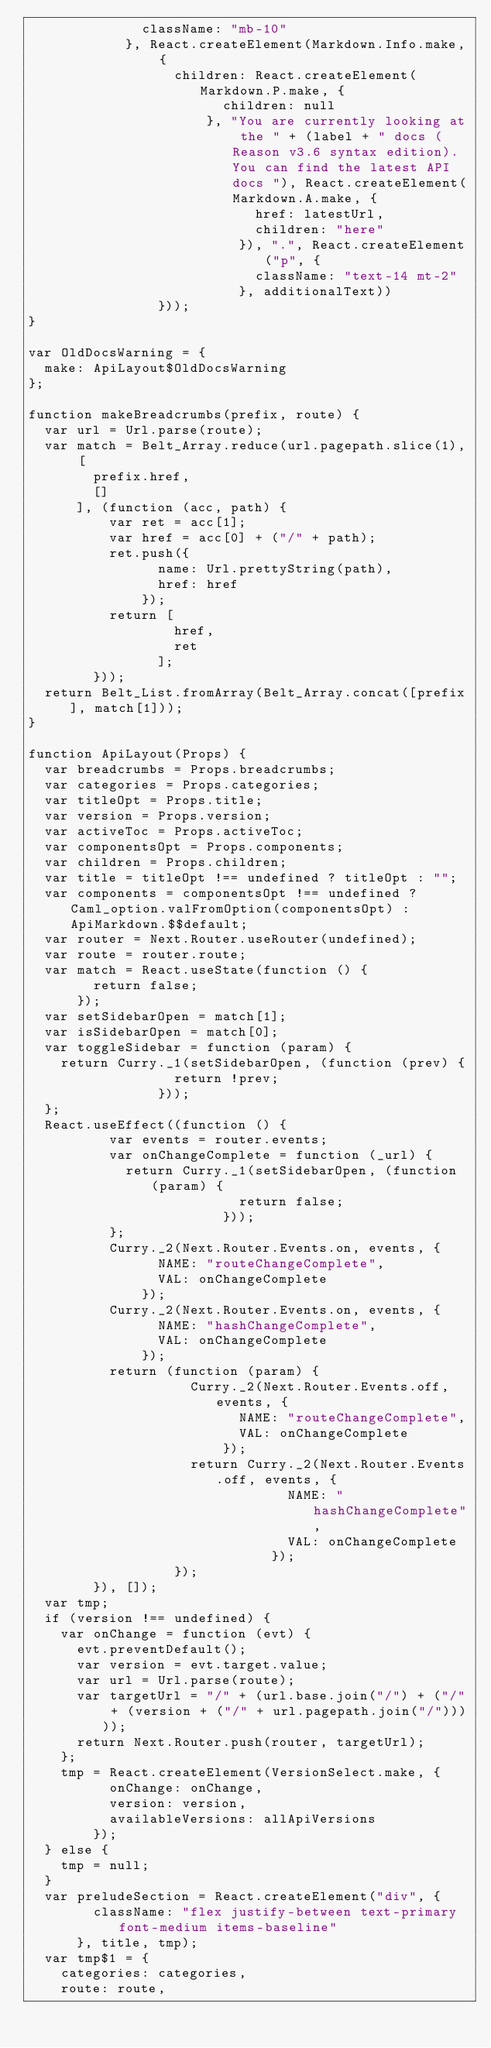Convert code to text. <code><loc_0><loc_0><loc_500><loc_500><_JavaScript_>              className: "mb-10"
            }, React.createElement(Markdown.Info.make, {
                  children: React.createElement(Markdown.P.make, {
                        children: null
                      }, "You are currently looking at the " + (label + " docs (Reason v3.6 syntax edition). You can find the latest API docs "), React.createElement(Markdown.A.make, {
                            href: latestUrl,
                            children: "here"
                          }), ".", React.createElement("p", {
                            className: "text-14 mt-2"
                          }, additionalText))
                }));
}

var OldDocsWarning = {
  make: ApiLayout$OldDocsWarning
};

function makeBreadcrumbs(prefix, route) {
  var url = Url.parse(route);
  var match = Belt_Array.reduce(url.pagepath.slice(1), [
        prefix.href,
        []
      ], (function (acc, path) {
          var ret = acc[1];
          var href = acc[0] + ("/" + path);
          ret.push({
                name: Url.prettyString(path),
                href: href
              });
          return [
                  href,
                  ret
                ];
        }));
  return Belt_List.fromArray(Belt_Array.concat([prefix], match[1]));
}

function ApiLayout(Props) {
  var breadcrumbs = Props.breadcrumbs;
  var categories = Props.categories;
  var titleOpt = Props.title;
  var version = Props.version;
  var activeToc = Props.activeToc;
  var componentsOpt = Props.components;
  var children = Props.children;
  var title = titleOpt !== undefined ? titleOpt : "";
  var components = componentsOpt !== undefined ? Caml_option.valFromOption(componentsOpt) : ApiMarkdown.$$default;
  var router = Next.Router.useRouter(undefined);
  var route = router.route;
  var match = React.useState(function () {
        return false;
      });
  var setSidebarOpen = match[1];
  var isSidebarOpen = match[0];
  var toggleSidebar = function (param) {
    return Curry._1(setSidebarOpen, (function (prev) {
                  return !prev;
                }));
  };
  React.useEffect((function () {
          var events = router.events;
          var onChangeComplete = function (_url) {
            return Curry._1(setSidebarOpen, (function (param) {
                          return false;
                        }));
          };
          Curry._2(Next.Router.Events.on, events, {
                NAME: "routeChangeComplete",
                VAL: onChangeComplete
              });
          Curry._2(Next.Router.Events.on, events, {
                NAME: "hashChangeComplete",
                VAL: onChangeComplete
              });
          return (function (param) {
                    Curry._2(Next.Router.Events.off, events, {
                          NAME: "routeChangeComplete",
                          VAL: onChangeComplete
                        });
                    return Curry._2(Next.Router.Events.off, events, {
                                NAME: "hashChangeComplete",
                                VAL: onChangeComplete
                              });
                  });
        }), []);
  var tmp;
  if (version !== undefined) {
    var onChange = function (evt) {
      evt.preventDefault();
      var version = evt.target.value;
      var url = Url.parse(route);
      var targetUrl = "/" + (url.base.join("/") + ("/" + (version + ("/" + url.pagepath.join("/")))));
      return Next.Router.push(router, targetUrl);
    };
    tmp = React.createElement(VersionSelect.make, {
          onChange: onChange,
          version: version,
          availableVersions: allApiVersions
        });
  } else {
    tmp = null;
  }
  var preludeSection = React.createElement("div", {
        className: "flex justify-between text-primary font-medium items-baseline"
      }, title, tmp);
  var tmp$1 = {
    categories: categories,
    route: route,</code> 